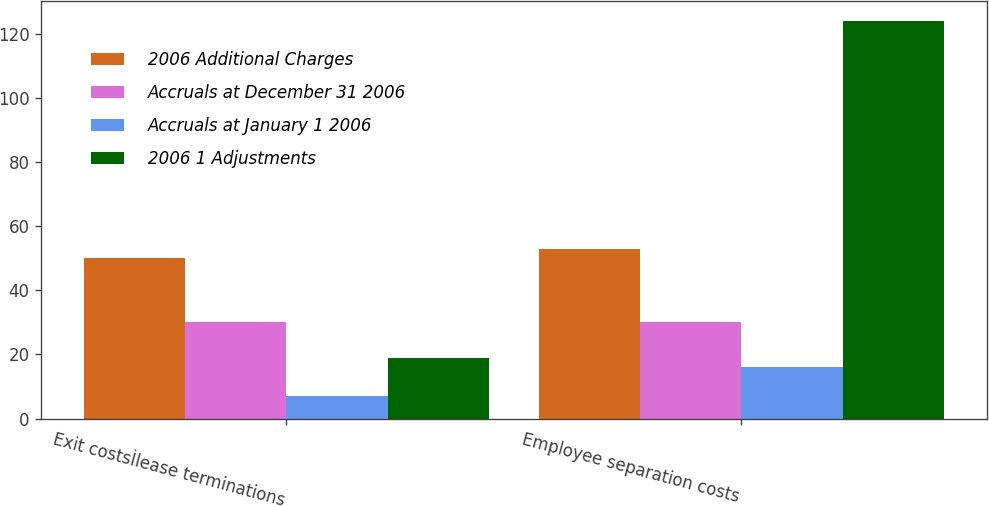<chart> <loc_0><loc_0><loc_500><loc_500><stacked_bar_chart><ecel><fcel>Exit costsÌlease terminations<fcel>Employee separation costs<nl><fcel>2006 Additional Charges<fcel>50<fcel>53<nl><fcel>Accruals at December 31 2006<fcel>30<fcel>30<nl><fcel>Accruals at January 1 2006<fcel>7<fcel>16<nl><fcel>2006 1 Adjustments<fcel>19<fcel>124<nl></chart> 